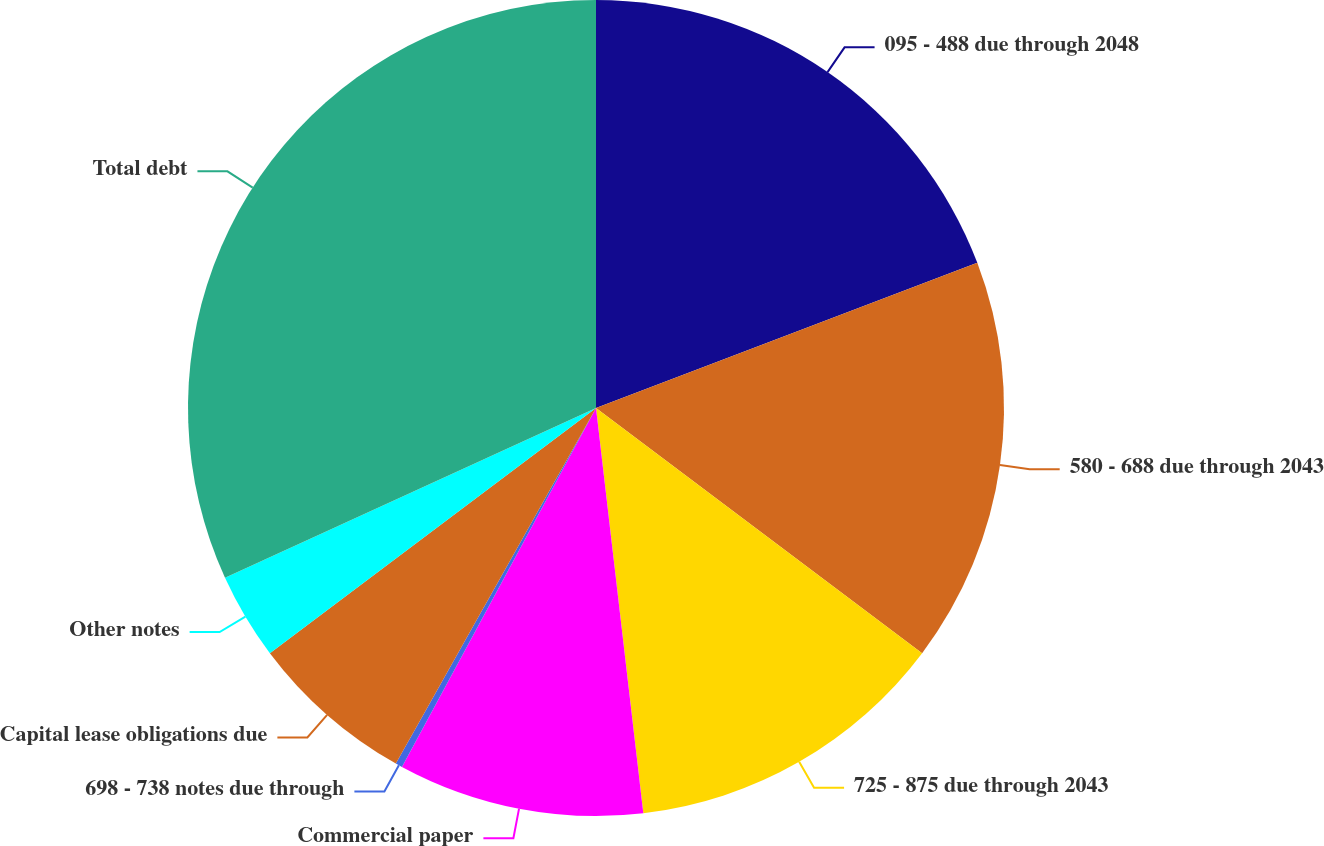<chart> <loc_0><loc_0><loc_500><loc_500><pie_chart><fcel>095 - 488 due through 2048<fcel>580 - 688 due through 2043<fcel>725 - 875 due through 2043<fcel>Commercial paper<fcel>698 - 738 notes due through<fcel>Capital lease obligations due<fcel>Other notes<fcel>Total debt<nl><fcel>19.21%<fcel>16.05%<fcel>12.89%<fcel>9.74%<fcel>0.27%<fcel>6.58%<fcel>3.43%<fcel>31.83%<nl></chart> 